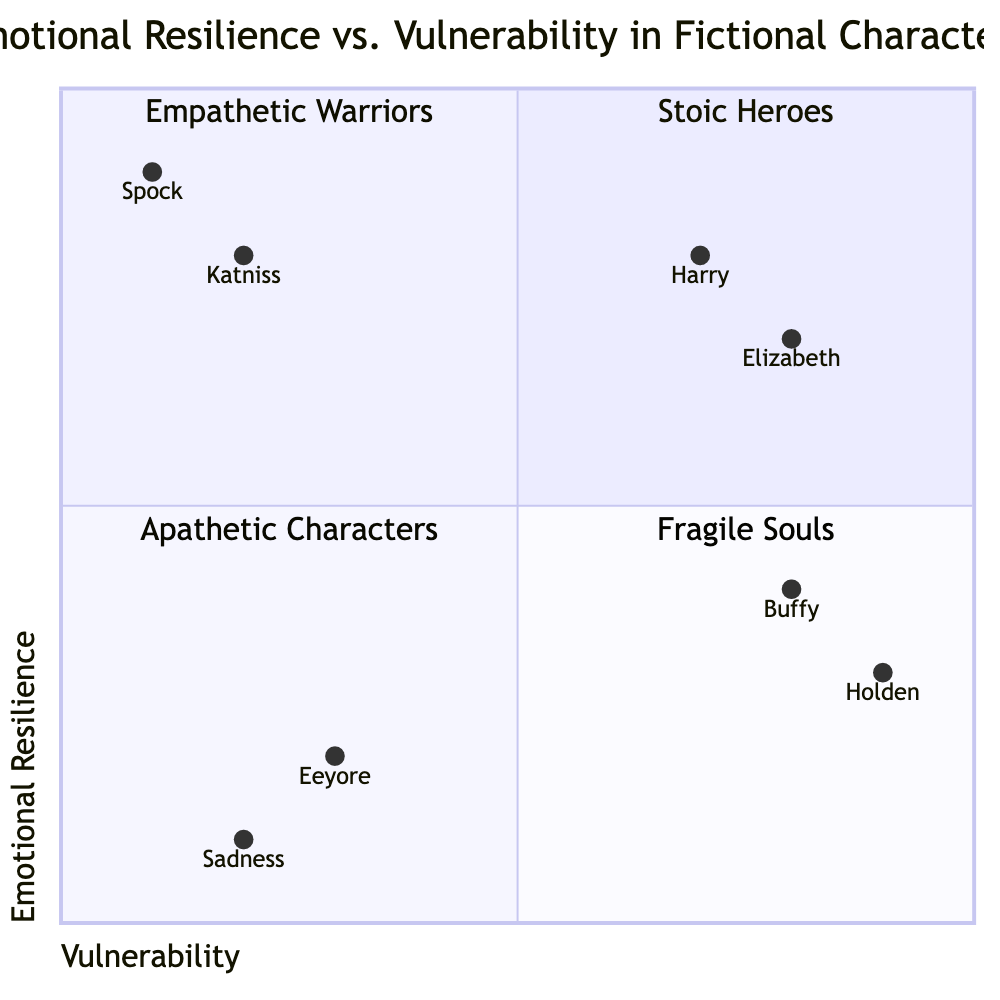What quadrant does Katniss Everdeen belong to? Katniss Everdeen is placed at coordinates [0.2, 0.8] in the diagram. The y-coordinate (0.8) indicates high emotional resilience, and the x-coordinate (0.2) indicates low vulnerability. Therefore, she belongs to the Stoic Heroes quadrant.
Answer: Stoic Heroes Which character is in the Fragile Souls quadrant? The Fragile Souls quadrant includes characters who exhibit high vulnerability and low resilience. The characters listed in this quadrant are Holden Caulfield and Buffy Summers. Both have high vulnerability and low resilience.
Answer: Holden Caulfield (or Buffy Summers) How many characters are in the Apathetic Characters quadrant? The Apathetic Characters quadrant contains characters with low emotional expression and low resilience. The characters Eeyore and Sadness are listed here, making a total of 2 characters.
Answer: 2 What are the coordinates of Elizabeth Bennet? Elizabeth Bennet is located at the coordinates [0.8, 0.7]. The x-coordinate of 0.8 indicates high vulnerability, and the y-coordinate of 0.7 indicates high emotional resilience.
Answer: [0.8, 0.7] Which two quadrants contain characters with high emotional resilience? Characters that exhibit high emotional resilience can be found in both the Stoic Heroes quadrant (with low vulnerability) and the Empathetic Warriors quadrant (with high vulnerability). Both quadrants showcasing such characters are: Stoic Heroes and Empathetic Warriors.
Answer: Stoic Heroes and Empathetic Warriors What character has the highest vulnerability in the diagram? The character with the highest vulnerability in the diagram is Holden Caulfield, with an x-coordinate of 0.9, placing him in the Fragile Souls quadrant.
Answer: Holden Caulfield Name a character from the Empathetic Warriors quadrant. The Empathetic Warriors quadrant includes characters who are emotionally expressive and resilient. Harry Potter is one example from this quadrant.
Answer: Harry Potter Which character shows both high vulnerability and high resilience? The characters in the Empathetic Warriors quadrant show both high vulnerability and high resilience. Harry Potter is one of the examples of such characters in this quadrant.
Answer: Harry Potter 